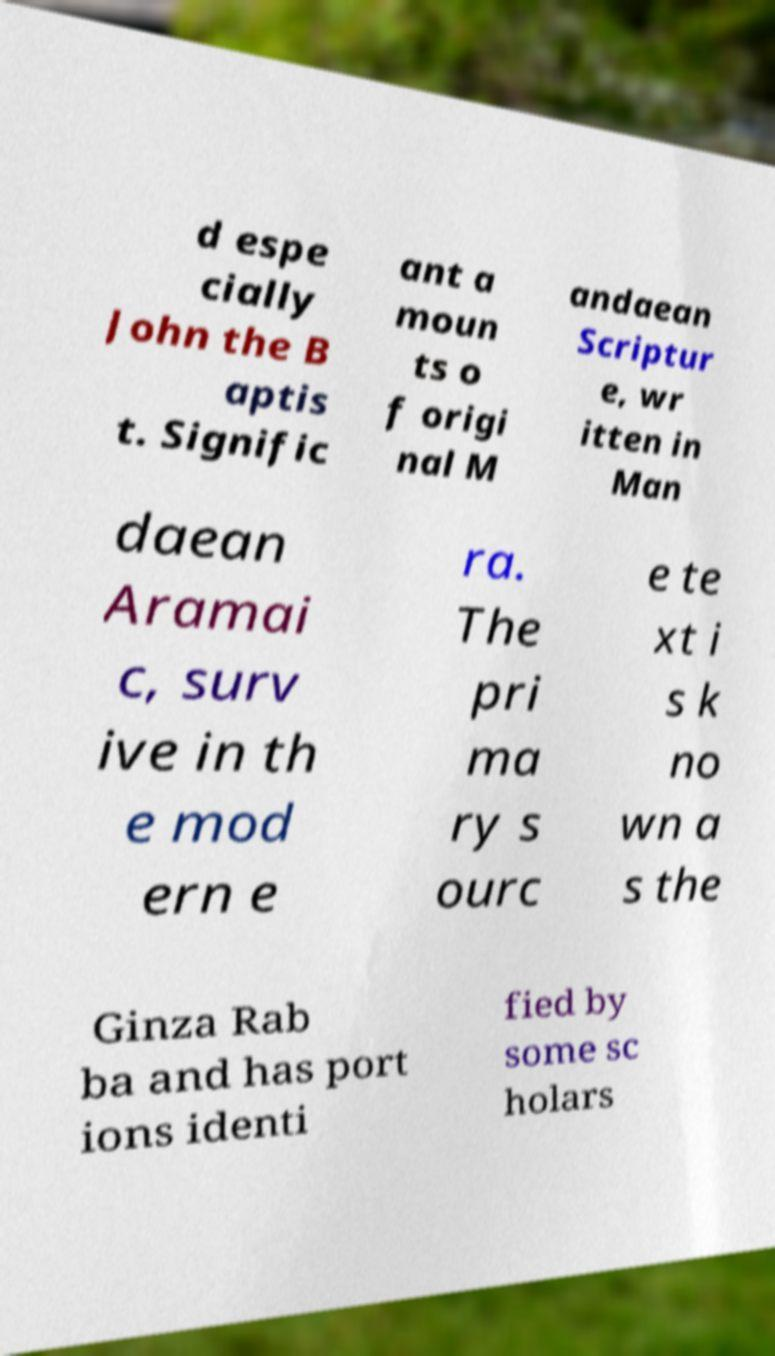What messages or text are displayed in this image? I need them in a readable, typed format. d espe cially John the B aptis t. Signific ant a moun ts o f origi nal M andaean Scriptur e, wr itten in Man daean Aramai c, surv ive in th e mod ern e ra. The pri ma ry s ourc e te xt i s k no wn a s the Ginza Rab ba and has port ions identi fied by some sc holars 